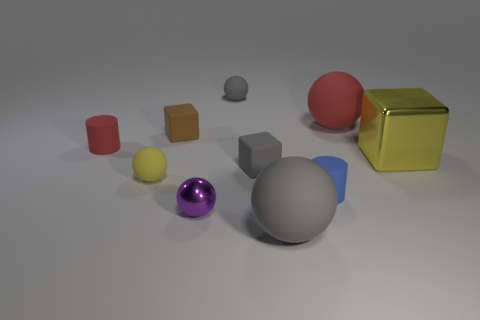There is a big red thing that is the same shape as the tiny yellow rubber object; what material is it?
Give a very brief answer. Rubber. The tiny red object that is the same material as the small gray cube is what shape?
Offer a terse response. Cylinder. What number of other tiny yellow rubber things are the same shape as the tiny yellow object?
Make the answer very short. 0. What shape is the small gray rubber thing that is in front of the small gray object that is behind the large red matte sphere?
Offer a very short reply. Cube. Does the shiny object that is on the right side of the blue rubber cylinder have the same size as the small brown block?
Make the answer very short. No. There is a matte ball that is both to the right of the small gray rubber ball and on the left side of the large red rubber object; what size is it?
Your answer should be very brief. Large. How many cylinders have the same size as the brown object?
Your answer should be very brief. 2. How many tiny yellow objects are right of the block on the left side of the small purple shiny ball?
Offer a very short reply. 0. Do the small rubber ball in front of the large red rubber ball and the metal cube have the same color?
Give a very brief answer. Yes. Is there a big gray thing to the left of the large object in front of the small gray block on the left side of the large gray thing?
Ensure brevity in your answer.  No. 